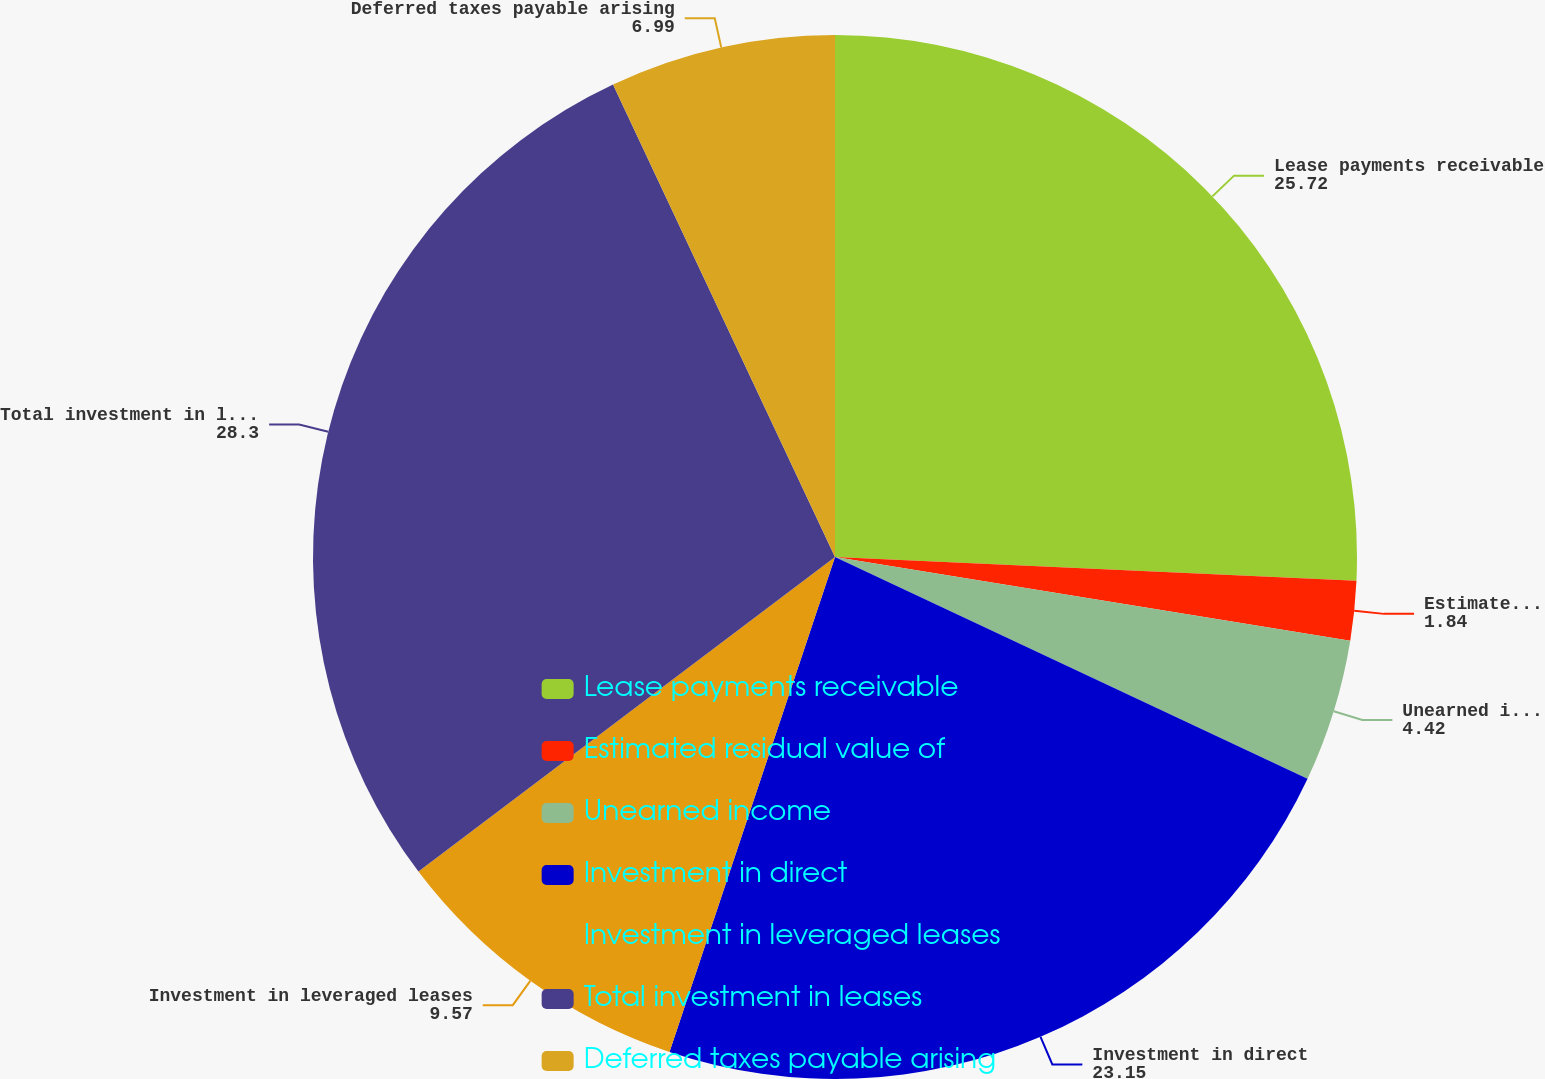Convert chart to OTSL. <chart><loc_0><loc_0><loc_500><loc_500><pie_chart><fcel>Lease payments receivable<fcel>Estimated residual value of<fcel>Unearned income<fcel>Investment in direct<fcel>Investment in leveraged leases<fcel>Total investment in leases<fcel>Deferred taxes payable arising<nl><fcel>25.72%<fcel>1.84%<fcel>4.42%<fcel>23.15%<fcel>9.57%<fcel>28.3%<fcel>6.99%<nl></chart> 